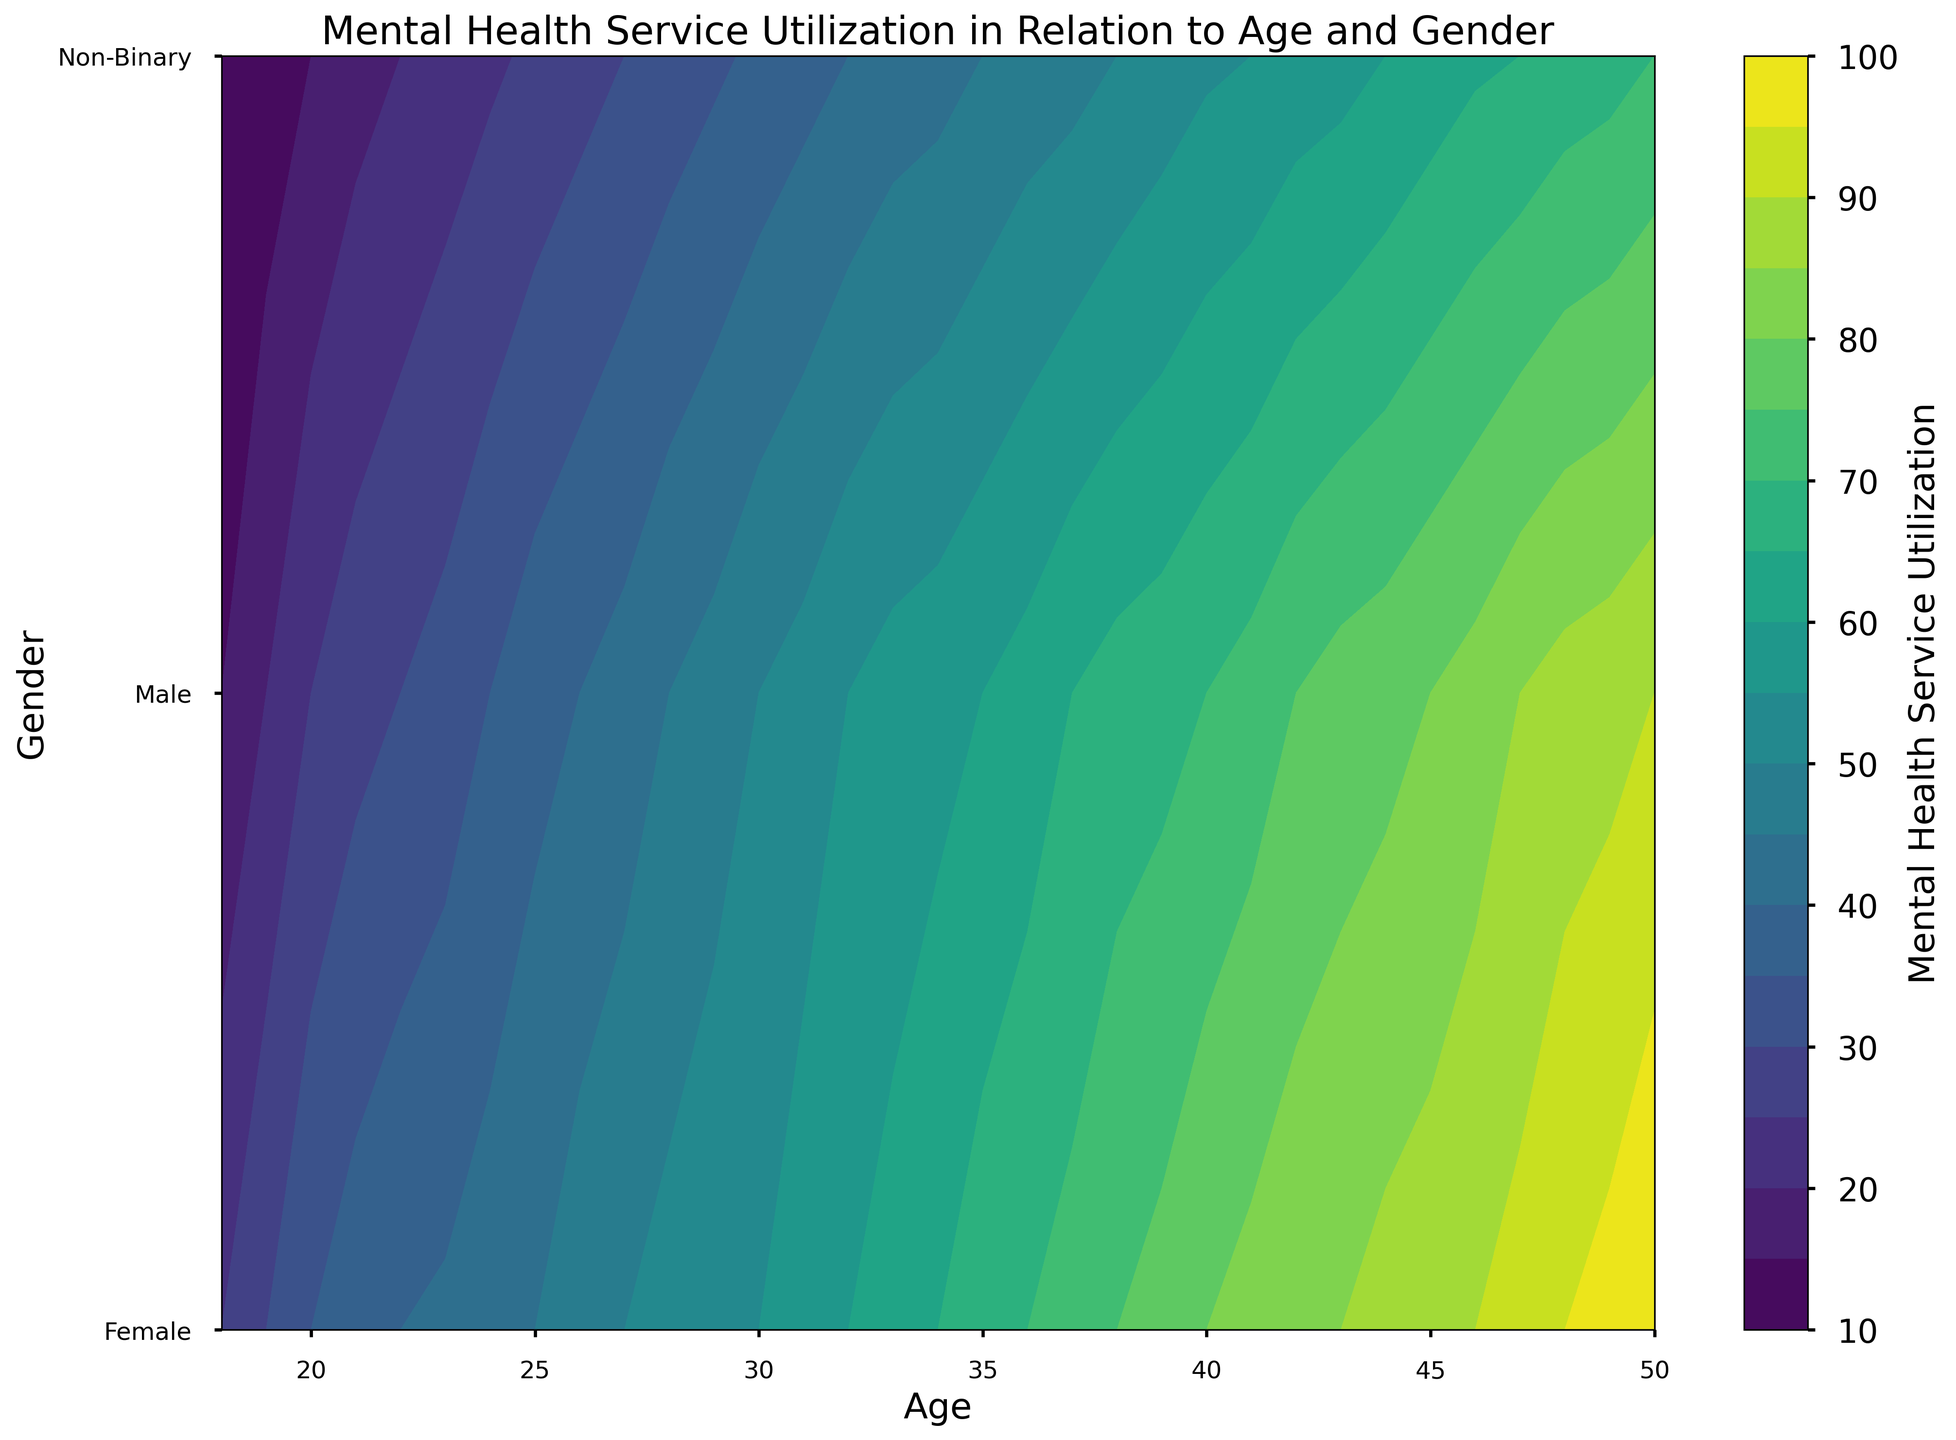Which age group shows the highest mental health service utilization for females? By inspecting the contour plot, locate the point where the age axis and female category intersect and identify the highest utilization value corresponding to that age.
Answer: 50 Between ages 30 and 35, which gender shows the steepest increase in mental health service utilization? Observe the contour lines within the age range of 30 to 35 for each gender. Identify which gender's color gradient changes the most rapidly, indicating a steep increase.
Answer: Female How does the mental health service utilization compare between males and non-binary individuals at age 25? Locate the contour lines for age 25 on the age axis and compare the utilization values for males and non-binary individuals.
Answer: Males have higher utilization What is the approximate difference in mental health service utilization between females aged 40 and 50? Find the utilization values for females at ages 40 and 50, then subtract the value at age 40 from the value at age 50.
Answer: 20 Identify the age and gender combination that has the lowest mental health service utilization below age 30. Examine the contour plot for age groups below 30 and identify the gender which shows the lightest color shade or lowest value.
Answer: Non-Binary, age 18 How does the mental health service utilization for non-binary individuals change from age 30 to age 40? Identify the change in contour colors for non-binary individuals from age 30 to 40, noting the differences in value.
Answer: It increases Which gender shows the smallest variation in mental health service utilization across all ages? Compare the contour gradients for each gender across all ages, looking for the one with the most consistent color gradient or minimal variation in values.
Answer: Female At what age do males and females have equal mental health service utilization? Locate the point on the contour plot where the contour lines for males and females intersect, indicating equal values.
Answer: They do not intersect 